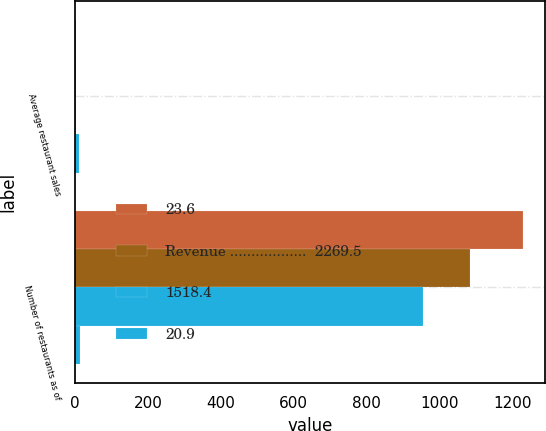Convert chart to OTSL. <chart><loc_0><loc_0><loc_500><loc_500><stacked_bar_chart><ecel><fcel>Average restaurant sales<fcel>Number of restaurants as of<nl><fcel>23.6<fcel>2.01<fcel>1230<nl><fcel>Revenue ..................  2269.5<fcel>1.84<fcel>1084<nl><fcel>1518.4<fcel>1.73<fcel>956<nl><fcel>20.9<fcel>9.4<fcel>13.5<nl></chart> 